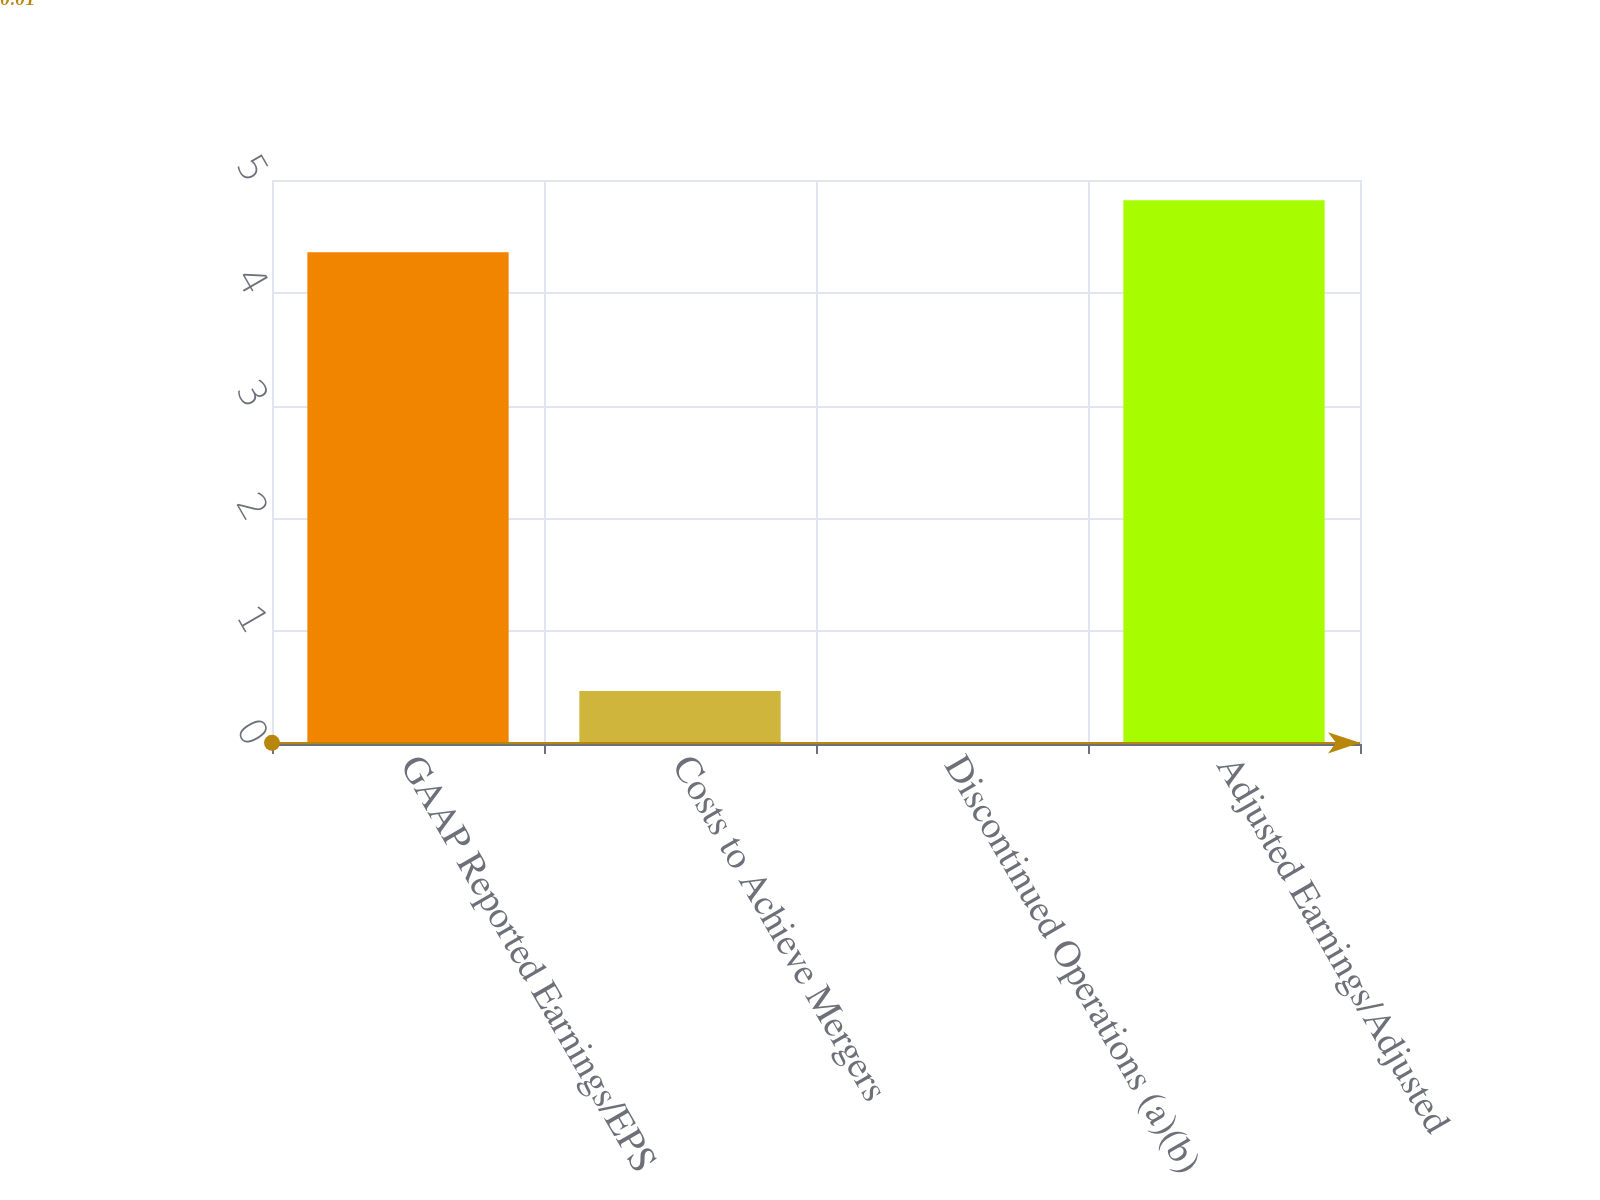Convert chart to OTSL. <chart><loc_0><loc_0><loc_500><loc_500><bar_chart><fcel>GAAP Reported Earnings/EPS<fcel>Costs to Achieve Mergers<fcel>Discontinued Operations (a)(b)<fcel>Adjusted Earnings/Adjusted<nl><fcel>4.36<fcel>0.47<fcel>0.01<fcel>4.82<nl></chart> 